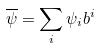Convert formula to latex. <formula><loc_0><loc_0><loc_500><loc_500>\overline { \psi } = \sum _ { i } \psi _ { i } b ^ { i }</formula> 